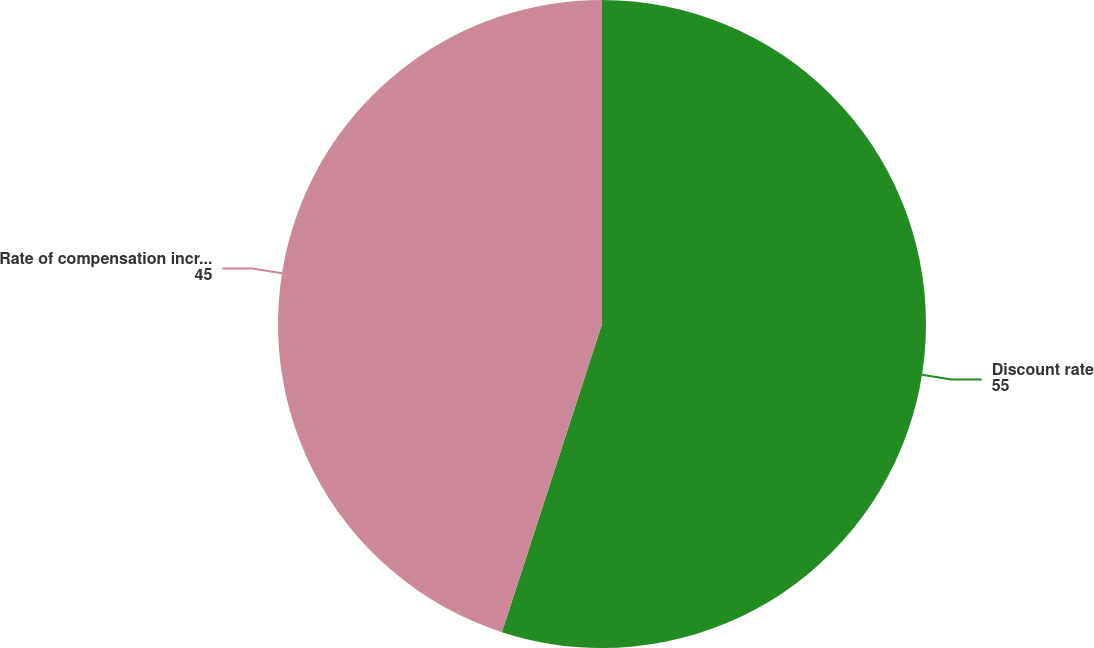Convert chart. <chart><loc_0><loc_0><loc_500><loc_500><pie_chart><fcel>Discount rate<fcel>Rate of compensation increase<nl><fcel>55.0%<fcel>45.0%<nl></chart> 